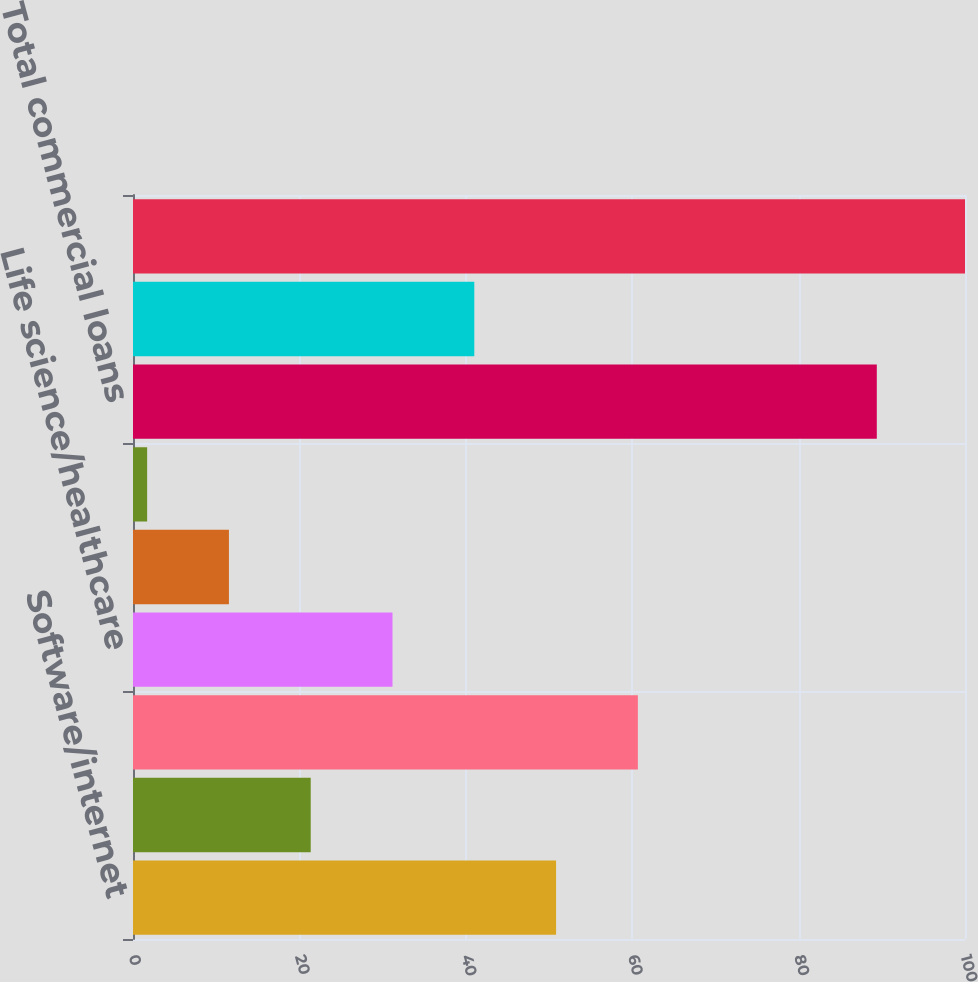Convert chart to OTSL. <chart><loc_0><loc_0><loc_500><loc_500><bar_chart><fcel>Software/internet<fcel>Hardware<fcel>Private equity/venture capital<fcel>Life science/healthcare<fcel>Premium wine<fcel>Other<fcel>Total commercial loans<fcel>Consumer loans<fcel>Total<nl><fcel>50.85<fcel>21.36<fcel>60.68<fcel>31.19<fcel>11.53<fcel>1.7<fcel>89.4<fcel>41.02<fcel>100<nl></chart> 